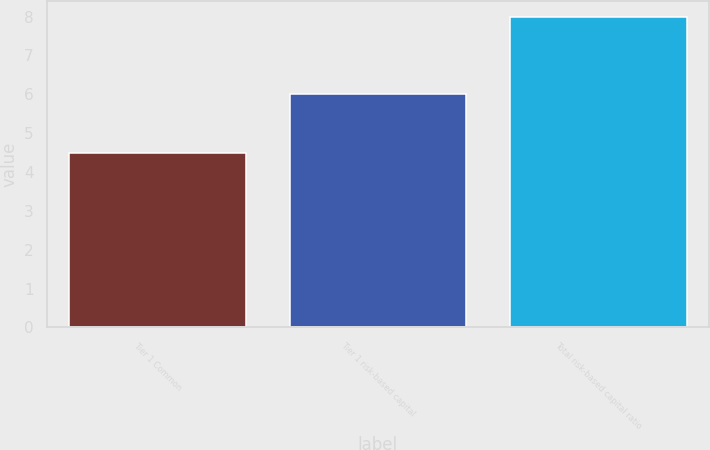<chart> <loc_0><loc_0><loc_500><loc_500><bar_chart><fcel>Tier 1 Common<fcel>Tier 1 risk-based capital<fcel>Total risk-based capital ratio<nl><fcel>4.5<fcel>6<fcel>8<nl></chart> 